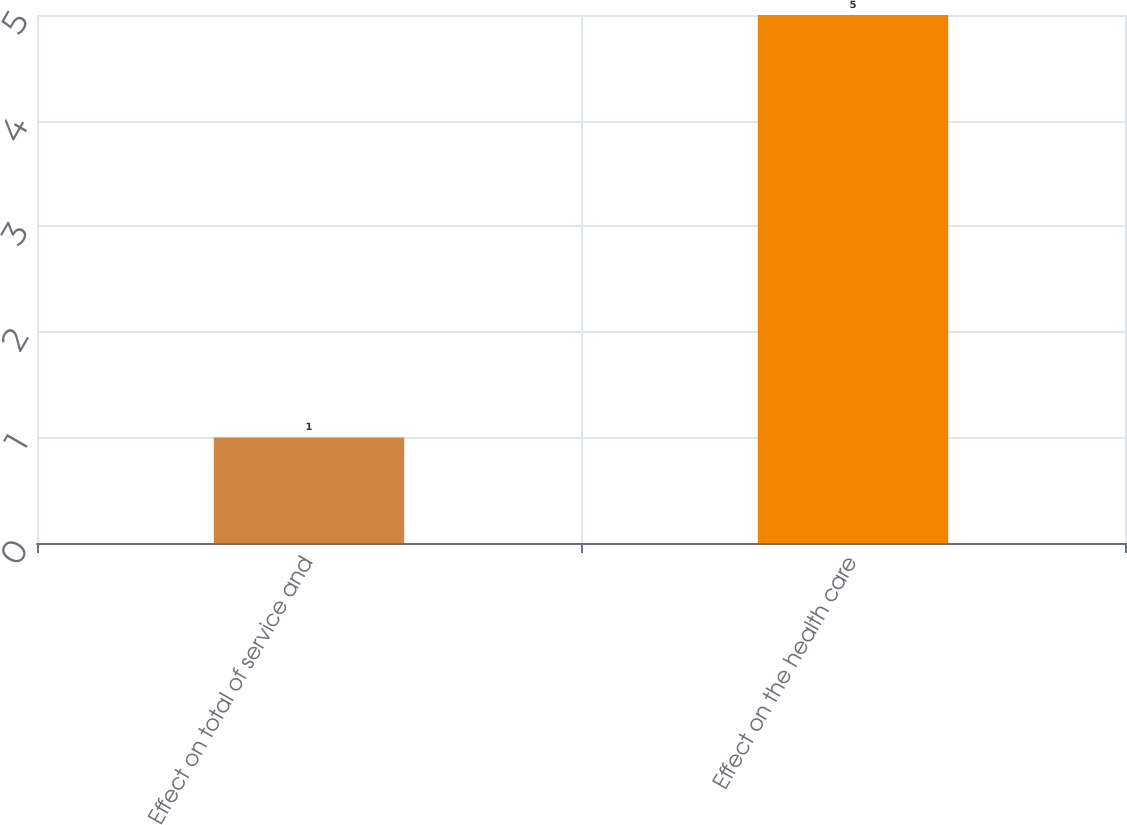Convert chart to OTSL. <chart><loc_0><loc_0><loc_500><loc_500><bar_chart><fcel>Effect on total of service and<fcel>Effect on the health care<nl><fcel>1<fcel>5<nl></chart> 